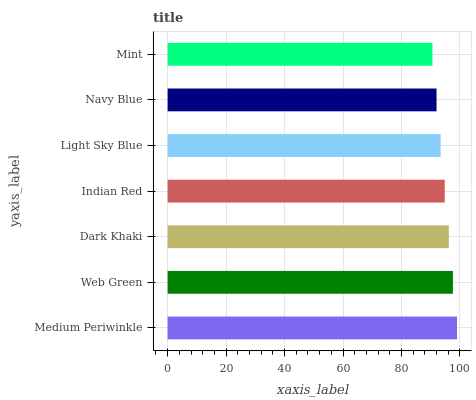Is Mint the minimum?
Answer yes or no. Yes. Is Medium Periwinkle the maximum?
Answer yes or no. Yes. Is Web Green the minimum?
Answer yes or no. No. Is Web Green the maximum?
Answer yes or no. No. Is Medium Periwinkle greater than Web Green?
Answer yes or no. Yes. Is Web Green less than Medium Periwinkle?
Answer yes or no. Yes. Is Web Green greater than Medium Periwinkle?
Answer yes or no. No. Is Medium Periwinkle less than Web Green?
Answer yes or no. No. Is Indian Red the high median?
Answer yes or no. Yes. Is Indian Red the low median?
Answer yes or no. Yes. Is Light Sky Blue the high median?
Answer yes or no. No. Is Mint the low median?
Answer yes or no. No. 